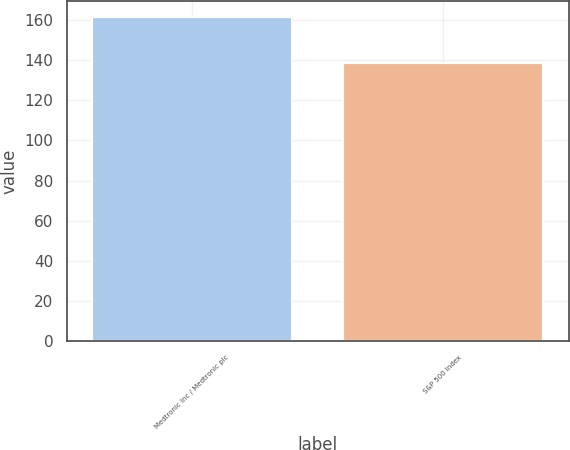<chart> <loc_0><loc_0><loc_500><loc_500><bar_chart><fcel>Medtronic Inc / Medtronic plc<fcel>S&P 500 Index<nl><fcel>161.43<fcel>138.69<nl></chart> 